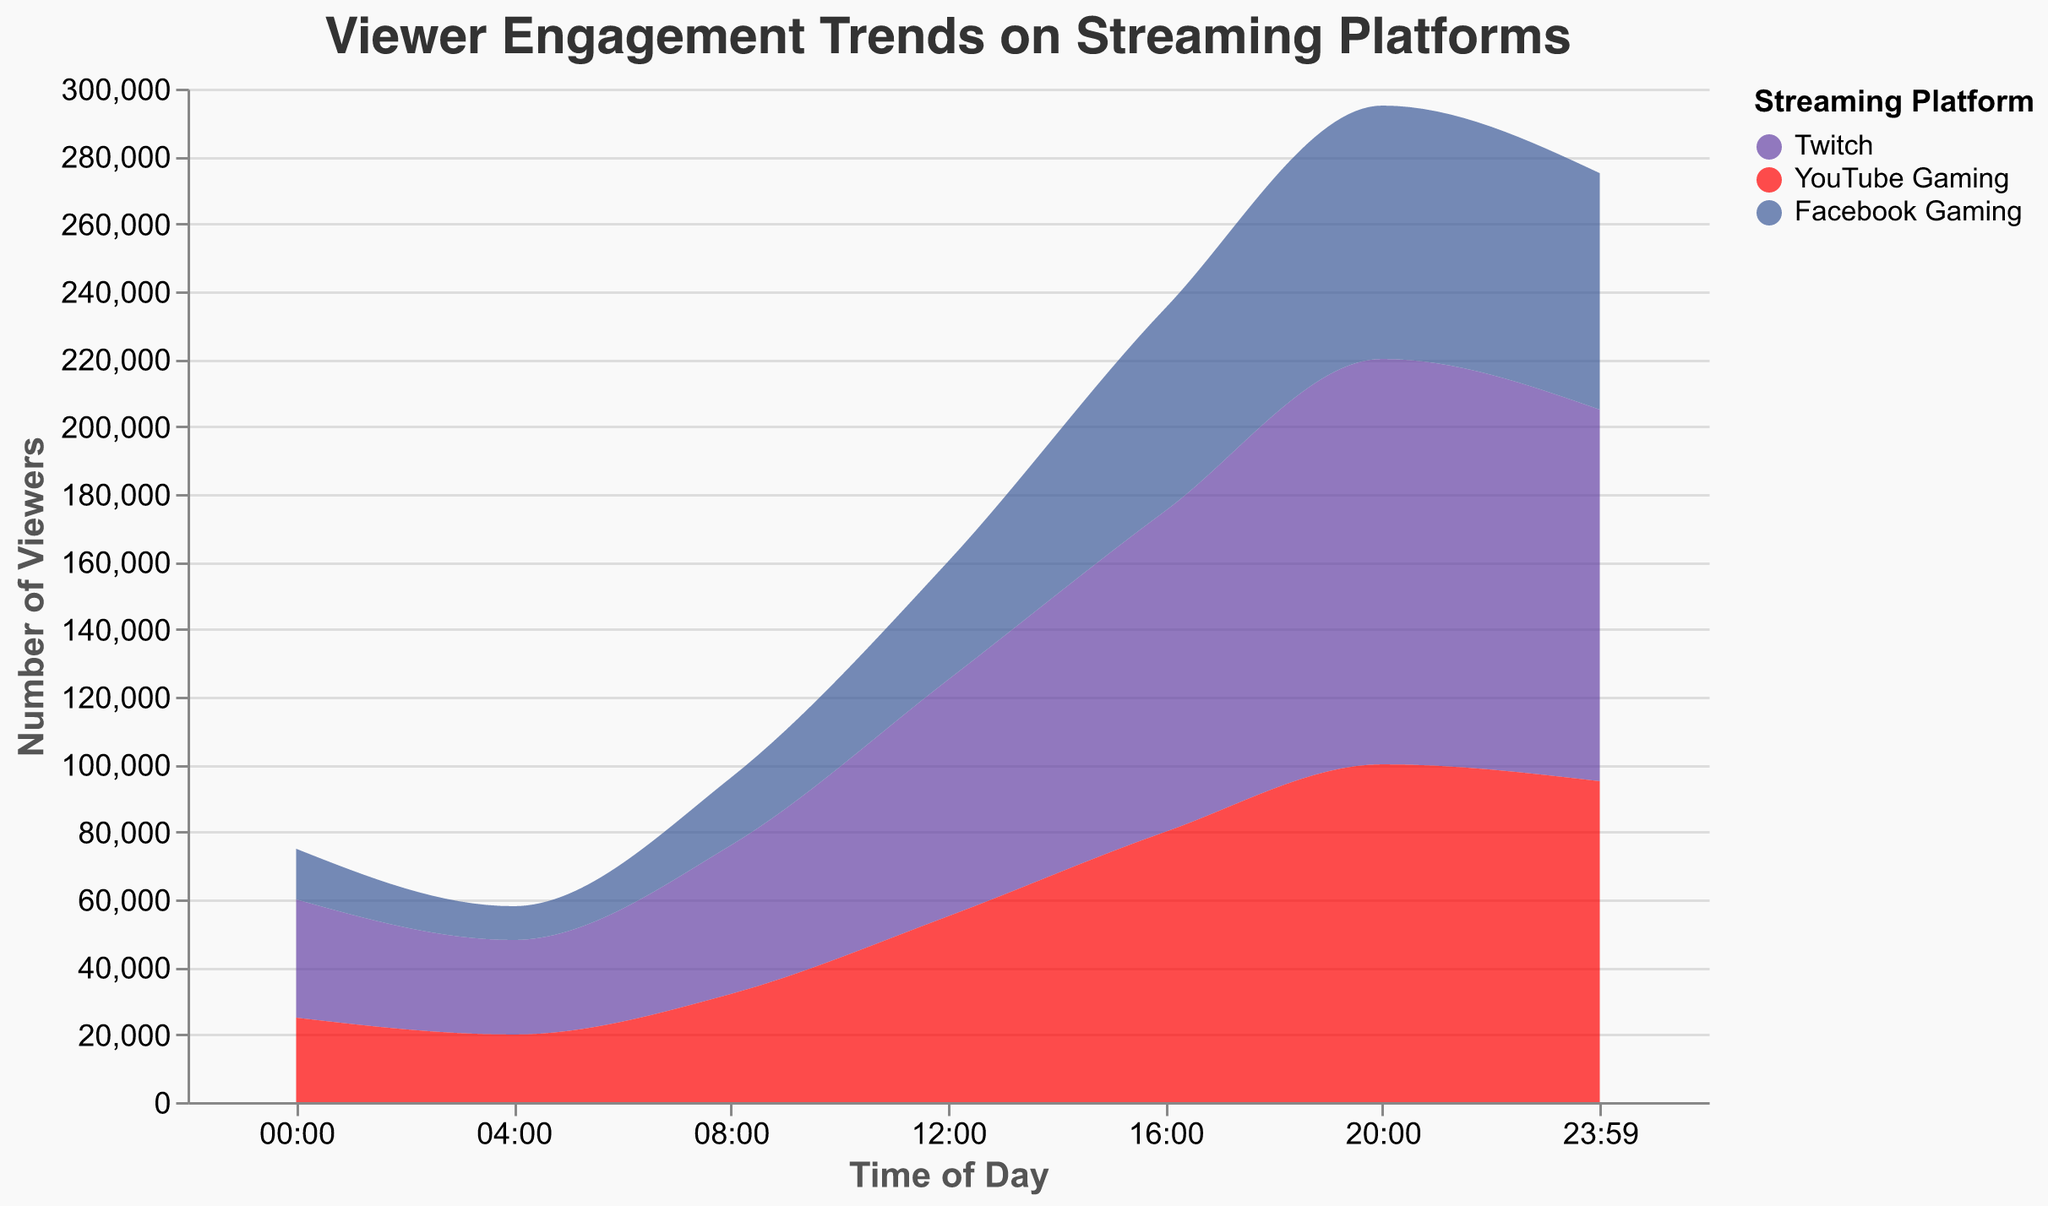What is the peak viewer count for Twitch? The peak viewer count for Twitch can be found by looking for the highest value in the area corresponding to Twitch. The peak occurs at 20:00 with 120,000 viewers.
Answer: 120,000 At what time does YouTube Gaming have the least viewer engagement? To determine the time of least engagement, look at the lowest point in the YouTube Gaming area. This occurs at 04:00 with 20,000 viewers.
Answer: 04:00 How does the viewer count for Facebook Gaming at 12:00 compare to Twitch at the same time? Compare the values for both platforms at 12:00. Facebook Gaming has 35,000 viewers while Twitch has 70,000 viewers. Twitch has double the viewers of Facebook Gaming at 12:00.
Answer: Twitch has double the viewers What is the overall trend of viewer engagement for all platforms from 16:00 to 20:00? From 16:00 to 20:00, there is a noticeable increase in viewer count across all platforms. Twitch increases from 95,000 to 120,000; YouTube Gaming increases from 80,000 to 100,000; and Facebook Gaming increases from 60,000 to 75,000.
Answer: Increasing trend What are the differences in viewer counts between 00:00 and 23:59 for each platform? Identify the viewer counts at 00:00 and 23:59 for each platform and calculate the difference. For Twitch, 00:00 has 35,000 and 23:59 has 110,000 (difference: 75,000). For YouTube Gaming, 00:00 has 25,000 and 23:59 has 95,000 (difference: 70,000). For Facebook Gaming, 00:00 has 15,000 and 23:59 has 70,000 (difference: 55,000).
Answer: Twitch: 75,000, YouTube Gaming: 70,000, Facebook Gaming: 55,000 What is the total viewer count combined for all platforms at 08:00? Add the viewer counts of all platforms at 08:00. Twitch has 44,000, YouTube Gaming has 32,000, and Facebook Gaming has 20,000, giving a total of 96,000.
Answer: 96,000 Which platform has the most stable viewer engagement throughout the day? Stability can be judged by the amount of fluctuation in the viewer count. Facebook Gaming shows the least fluctuation, starting at 15,000 and reaching a peak of 75,000, a difference of 60,000.
Answer: Facebook Gaming How does the viewer engagement trend for YouTube Gaming from 00:00 to 04:00 compare with Twitch? Look at changes from 00:00 to 04:00 for both platforms. YouTube Gaming decreases from 25,000 to 20,000 (down 5,000). Twitch decreases from 35,000 to 28,000 (down 7,000).
Answer: Both decrease但 Twitch's decrease is greater What is the average viewer count for Twitch across all times shown? Add up the viewer counts for Twitch and divide by the number of times. Sum is (35,000 + 28,000 + 44,000 + 70,000 + 95,000 + 120,000 + 110,000) = 502,000. Divided by 7, the average is 71,714.
Answer: 71,714 